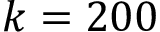Convert formula to latex. <formula><loc_0><loc_0><loc_500><loc_500>k = 2 0 0</formula> 